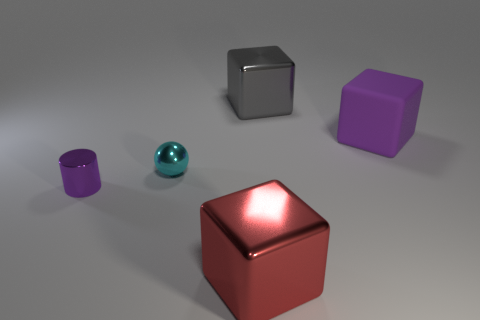How many objects are there in the image? There are five objects in the image: one red block, one purple block, one grey block, one turquoise sphere, and one purple cylinder.  Do the objects have anything in common? Yes, they all have a glossy surface which reflects light, indicating they might be made from similar materials. They all have simple geometric shapes as well. 